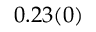<formula> <loc_0><loc_0><loc_500><loc_500>0 . 2 3 ( 0 )</formula> 